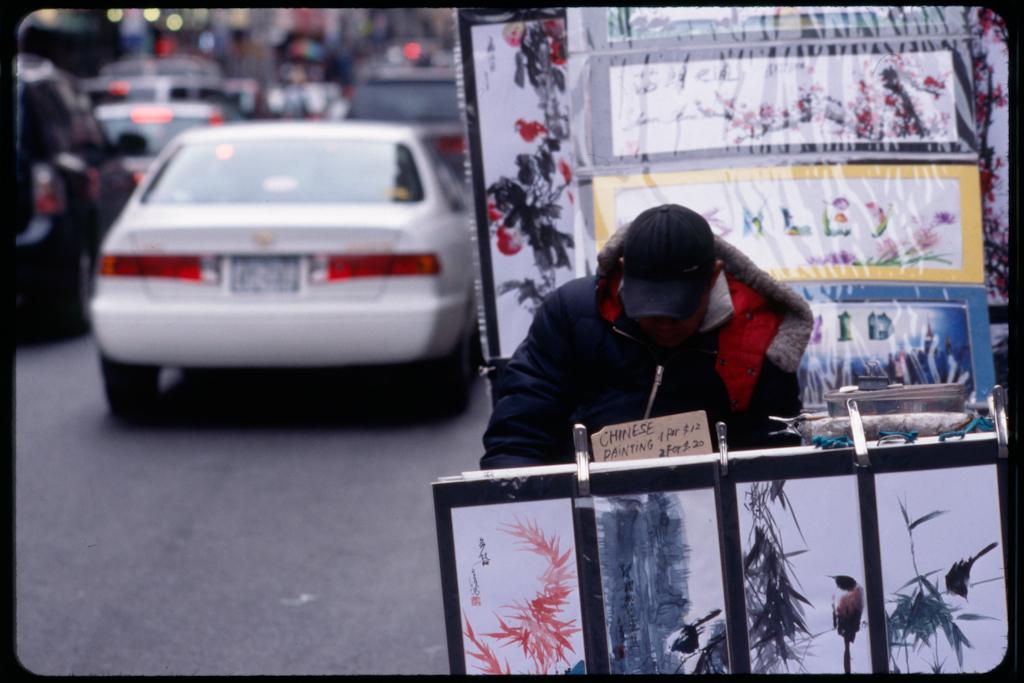What is the main subject of focus of the image? There is a photo in the image. Where is the table located in the image? The table is in the bottom right corner of the image. Who is standing near the table? A person is standing behind the table. What can be seen in the background of the image? There are vehicles visible on the road behind the person. How many clovers can be seen growing on the table in the image? There are no clovers visible on the table in the image. What type of insect is crawling on the person's shoulder in the image? There are no insects visible on the person's shoulder in the image. 